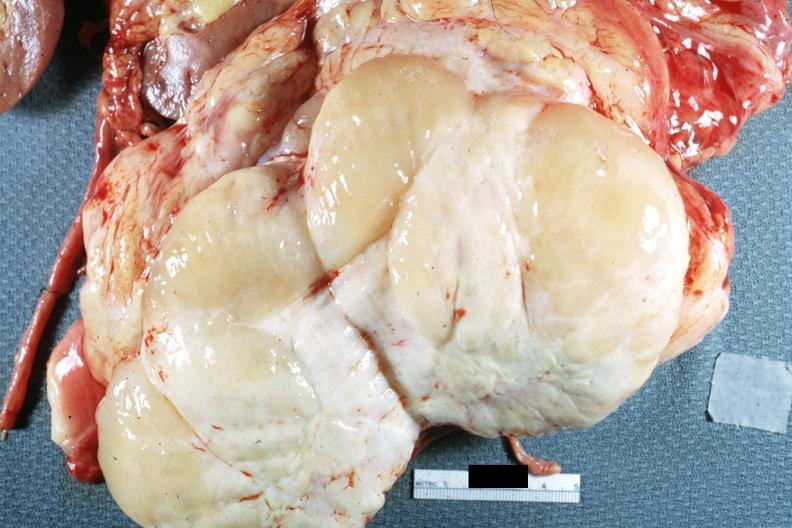how is nodular tumor cut surface natural color yellow and typical gross sarcoma?
Answer the question using a single word or phrase. White 